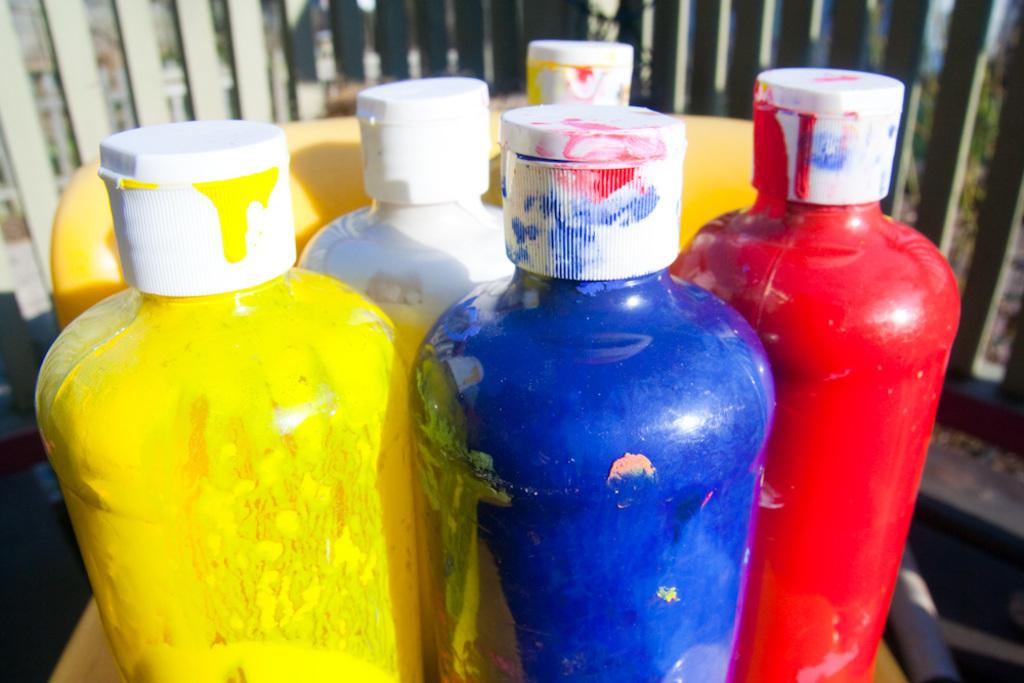What type of bottles are in the image? There are color bottles in the image. What are the bottles used for? The bottles contain paints. What color are the caps on the bottles? The bottles have white caps. What can be seen in the background of the image? There is a railing in the background of the image. How many laborers are working on the giraffe in the image? There is no giraffe or laborers present in the image. What type of operation is being performed on the bottles in the image? There is no operation being performed on the bottles in the image; they are simply sitting on a surface with their contents and caps visible. 